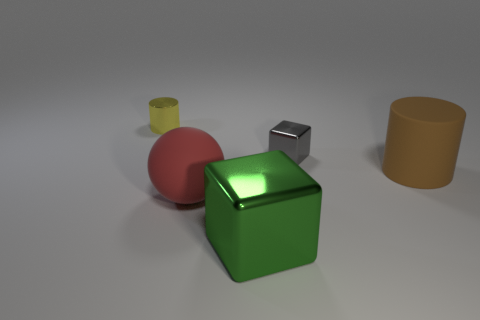Does the big brown matte thing have the same shape as the thing that is to the left of the rubber ball?
Offer a terse response. Yes. There is a brown rubber cylinder in front of the tiny shiny thing that is behind the gray metal object; what number of small gray metallic objects are behind it?
Offer a terse response. 1. What is the color of the other large object that is the same shape as the yellow metal thing?
Make the answer very short. Brown. Is there anything else that is the same shape as the brown matte object?
Your answer should be very brief. Yes. What number of spheres are big metallic objects or gray objects?
Offer a very short reply. 0. There is a small gray object; what shape is it?
Ensure brevity in your answer.  Cube. There is a gray shiny block; are there any gray things to the right of it?
Offer a terse response. No. Is the material of the brown cylinder the same as the small thing that is in front of the tiny yellow shiny object?
Make the answer very short. No. Do the big object that is behind the red matte sphere and the gray metallic thing have the same shape?
Keep it short and to the point. No. What number of large green blocks have the same material as the red object?
Your response must be concise. 0. 